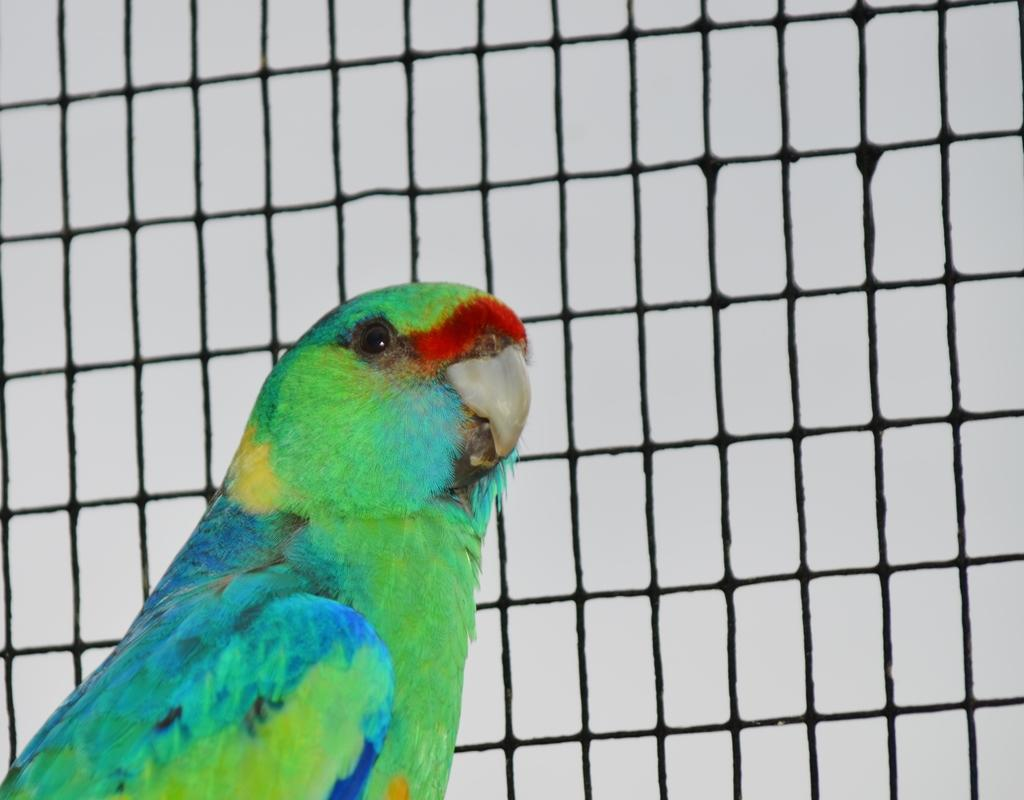What type of animal is in the image? There is a bird in the image. What colors can be seen on the bird? The bird has green, blue, red, and yellow colors. Where is the bird located in the image? The bird is on the left side of the image. What can be seen in the background of the image? There is a net in the background of the image. What decision does the bird make in the image? The image does not depict the bird making a decision, as it is a still image. What type of bit is present in the image? There is no bit present in the image. 